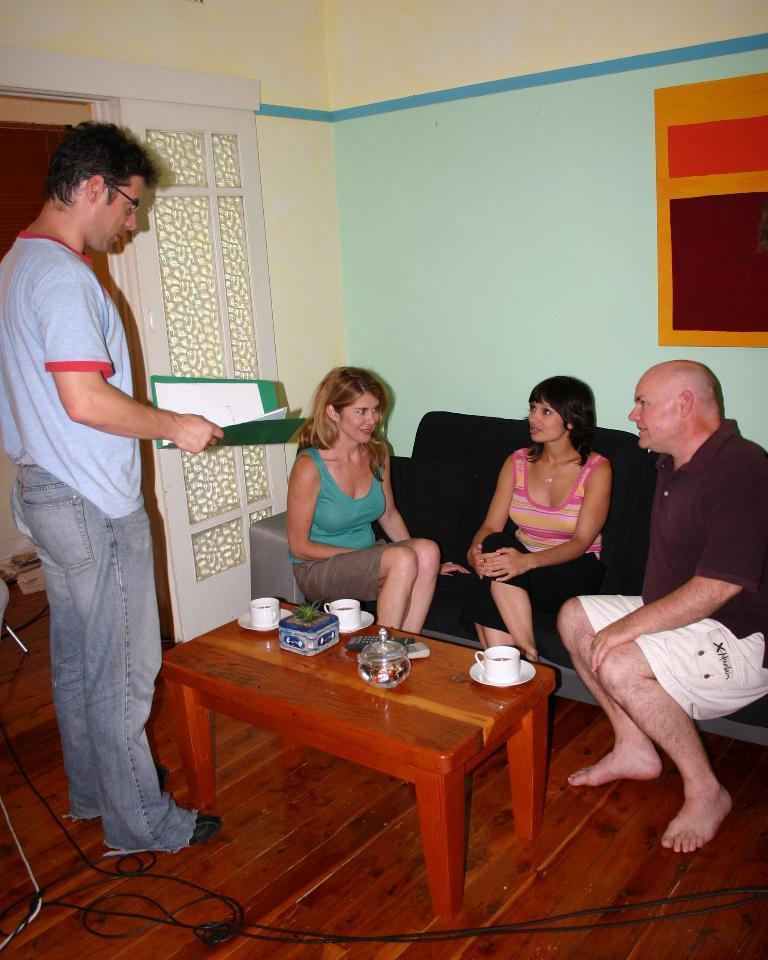In one or two sentences, can you explain what this image depicts? Here there are four people. Two ladies and two men. The two ladies and one man is sitting on the sofa. The man with grey t-shirt is standing. In front of them there is a table. On the table there is a coffee cup, jar and a box. Behind them there is a wall with the wallpaper. To the left side there is a door. 